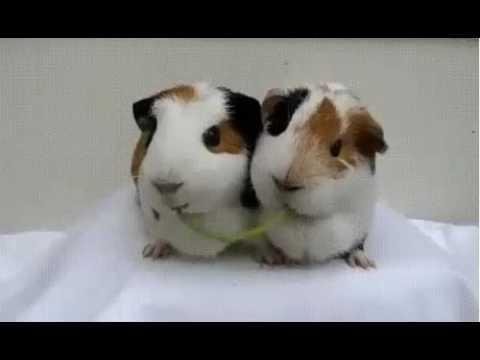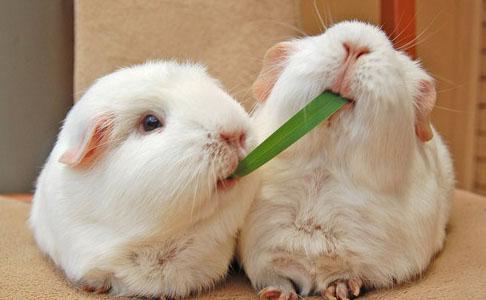The first image is the image on the left, the second image is the image on the right. For the images shown, is this caption "Two guinea pigs are chewing on the same item in each of the images." true? Answer yes or no. Yes. 